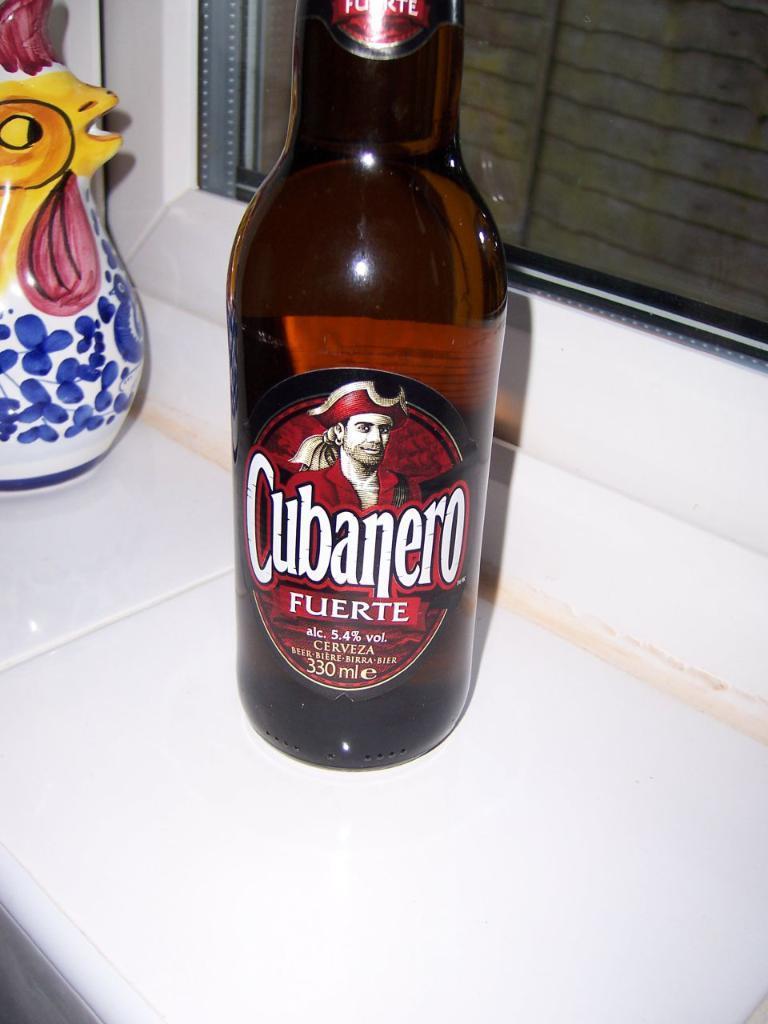Can you describe this image briefly? In this picture there is a bottle named CUBANERO FUERTE which is placed on top of a white table. In the top left corner of the image we find a beautiful object. In the background there is glass window. 